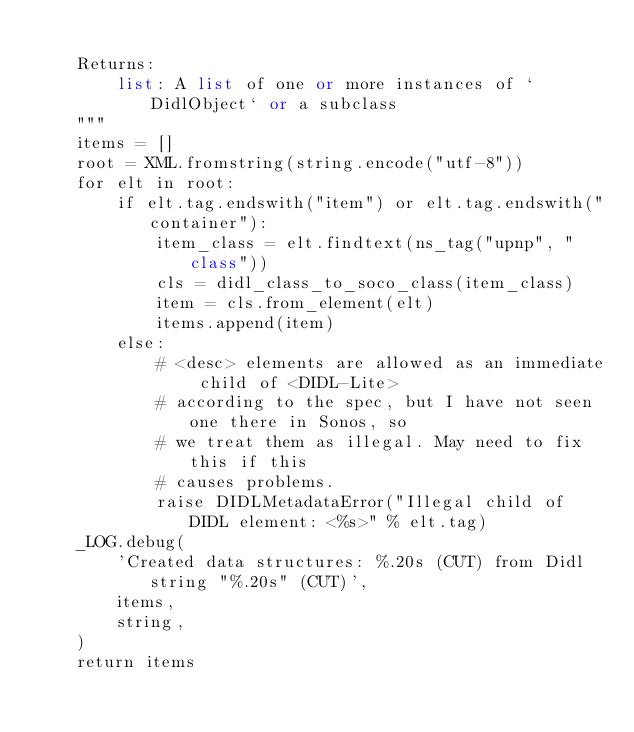<code> <loc_0><loc_0><loc_500><loc_500><_Python_>
    Returns:
        list: A list of one or more instances of `DidlObject` or a subclass
    """
    items = []
    root = XML.fromstring(string.encode("utf-8"))
    for elt in root:
        if elt.tag.endswith("item") or elt.tag.endswith("container"):
            item_class = elt.findtext(ns_tag("upnp", "class"))
            cls = didl_class_to_soco_class(item_class)
            item = cls.from_element(elt)
            items.append(item)
        else:
            # <desc> elements are allowed as an immediate child of <DIDL-Lite>
            # according to the spec, but I have not seen one there in Sonos, so
            # we treat them as illegal. May need to fix this if this
            # causes problems.
            raise DIDLMetadataError("Illegal child of DIDL element: <%s>" % elt.tag)
    _LOG.debug(
        'Created data structures: %.20s (CUT) from Didl string "%.20s" (CUT)',
        items,
        string,
    )
    return items
</code> 